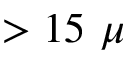Convert formula to latex. <formula><loc_0><loc_0><loc_500><loc_500>> 1 5 \mu</formula> 